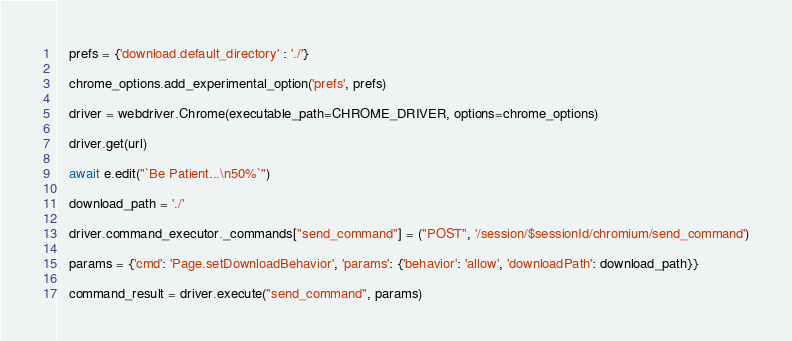Convert code to text. <code><loc_0><loc_0><loc_500><loc_500><_Python_>
   prefs = {'download.default_directory' : './'}

   chrome_options.add_experimental_option('prefs', prefs)

   driver = webdriver.Chrome(executable_path=CHROME_DRIVER, options=chrome_options)

   driver.get(url)

   await e.edit("`Be Patient...\n50%`")

   download_path = './'

   driver.command_executor._commands["send_command"] = ("POST", '/session/$sessionId/chromium/send_command')

   params = {'cmd': 'Page.setDownloadBehavior', 'params': {'behavior': 'allow', 'downloadPath': download_path}}

   command_result = driver.execute("send_command", params)
</code> 